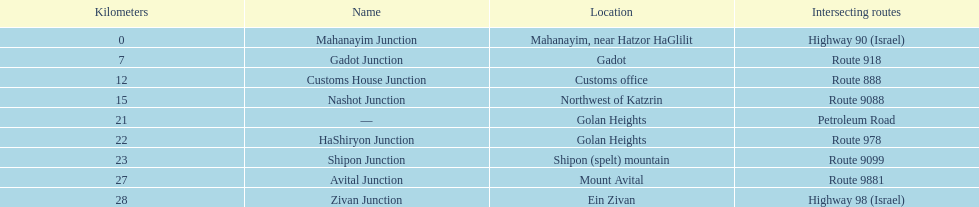Can you parse all the data within this table? {'header': ['Kilometers', 'Name', 'Location', 'Intersecting routes'], 'rows': [['0', 'Mahanayim Junction', 'Mahanayim, near Hatzor HaGlilit', 'Highway 90 (Israel)'], ['7', 'Gadot Junction', 'Gadot', 'Route 918'], ['12', 'Customs House Junction', 'Customs office', 'Route 888'], ['15', 'Nashot Junction', 'Northwest of Katzrin', 'Route 9088'], ['21', '—', 'Golan Heights', 'Petroleum Road'], ['22', 'HaShiryon Junction', 'Golan Heights', 'Route 978'], ['23', 'Shipon Junction', 'Shipon (spelt) mountain', 'Route 9099'], ['27', 'Avital Junction', 'Mount Avital', 'Route 9881'], ['28', 'Zivan Junction', 'Ein Zivan', 'Highway 98 (Israel)']]} Is nashot junction closer to shipon junction or avital junction? Shipon Junction. 